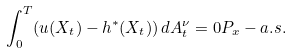Convert formula to latex. <formula><loc_0><loc_0><loc_500><loc_500>\int _ { 0 } ^ { T } ( u ( X _ { t } ) - h ^ { * } ( X _ { t } ) ) \, d A ^ { \nu } _ { t } = 0 P _ { x } - a . s .</formula> 